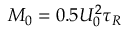<formula> <loc_0><loc_0><loc_500><loc_500>M _ { 0 } = 0 . 5 U _ { 0 } ^ { 2 } \tau _ { R }</formula> 